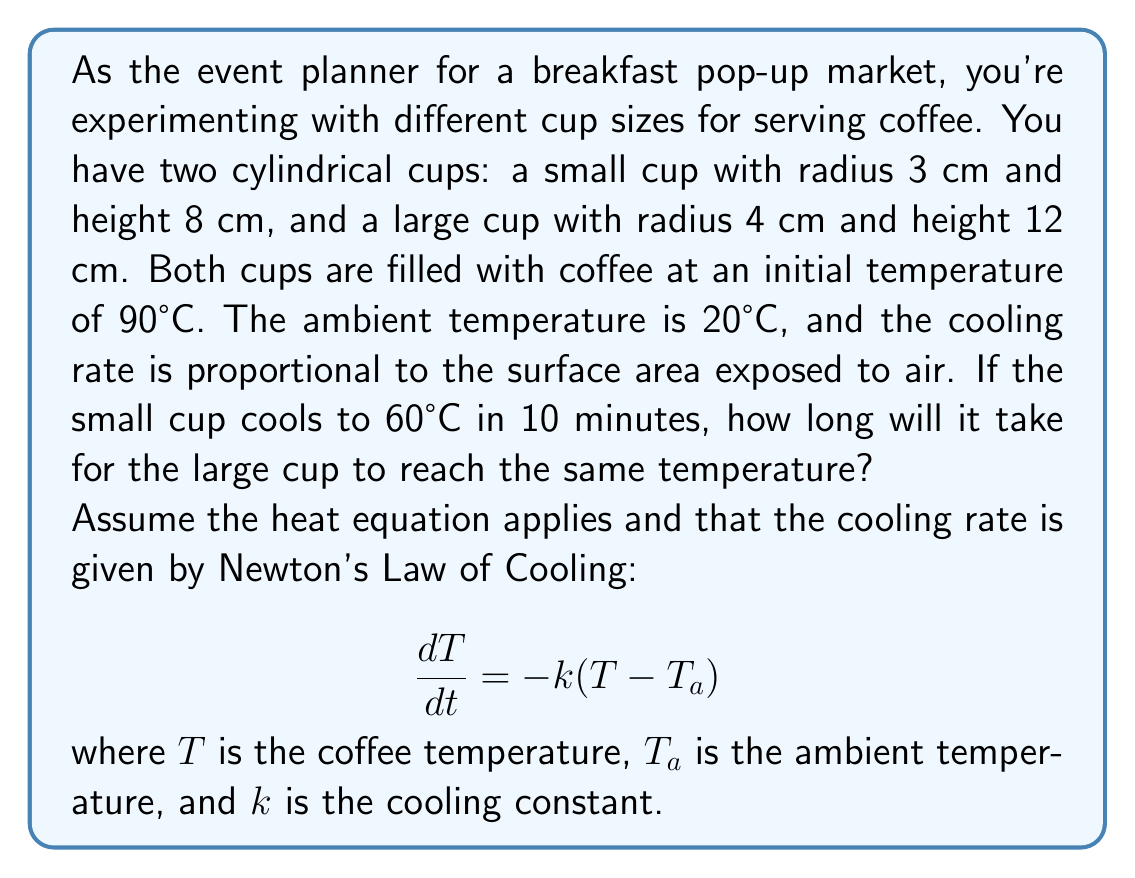Can you answer this question? Let's approach this step-by-step:

1) First, we need to find the cooling constant $k$ for the small cup. Using Newton's Law of Cooling:

   $$ T(t) = T_a + (T_0 - T_a)e^{-kt} $$

   where $T_0$ is the initial temperature.

2) For the small cup, we have:
   $T_0 = 90°C$, $T_a = 20°C$, $T(10) = 60°C$, $t = 10$ minutes

3) Substituting these values:

   $$ 60 = 20 + (90 - 20)e^{-10k} $$
   $$ 40 = 70e^{-10k} $$
   $$ \ln(\frac{4}{7}) = -10k $$
   $$ k = -\frac{1}{10}\ln(\frac{4}{7}) \approx 0.0560 \text{ min}^{-1} $$

4) The cooling rate is proportional to the surface area. For a cylindrical cup, the surface area exposed to air is:

   $$ A = \pi r^2 + 2\pi rh $$

5) For the small cup: $A_s = \pi(3^2) + 2\pi(3)(8) = 169.65 \text{ cm}^2$
   For the large cup: $A_l = \pi(4^2) + 2\pi(4)(12) = 351.86 \text{ cm}^2$

6) The ratio of cooling rates will be the same as the ratio of surface areas:

   $$ \frac{k_l}{k_s} = \frac{A_l}{A_s} = \frac{351.86}{169.65} \approx 2.0740 $$

7) So, $k_l = 2.0740 * 0.0560 = 0.1161 \text{ min}^{-1}$

8) Now we can use Newton's Law of Cooling for the large cup:

   $$ 60 = 20 + (90 - 20)e^{-0.1161t} $$
   $$ \frac{40}{70} = e^{-0.1161t} $$
   $$ \ln(\frac{4}{7}) = -0.1161t $$
   $$ t = -\frac{1}{0.1161}\ln(\frac{4}{7}) \approx 4.82 \text{ minutes} $$

Therefore, it will take approximately 4.82 minutes for the large cup to cool to 60°C.
Answer: 4.82 minutes 